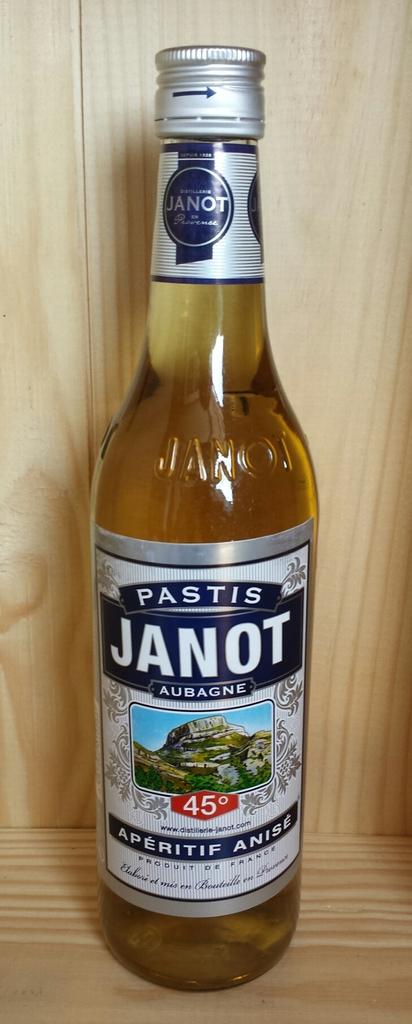What brand of beer is it?
Provide a succinct answer. Pastis janot. What is the number in red?
Provide a succinct answer. 45. 